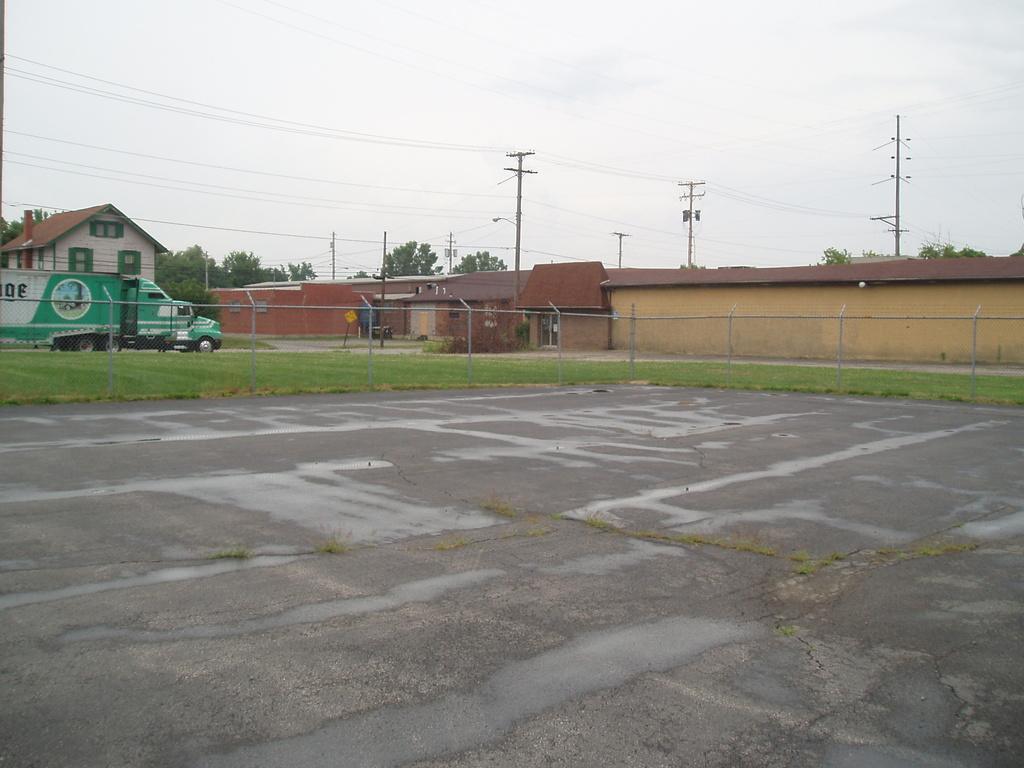Can you describe this image briefly? In this image we can see road, fence, grass on the ground, electric poles, houses, windows, wires, trees, board on a pole and clouds in the sky. 